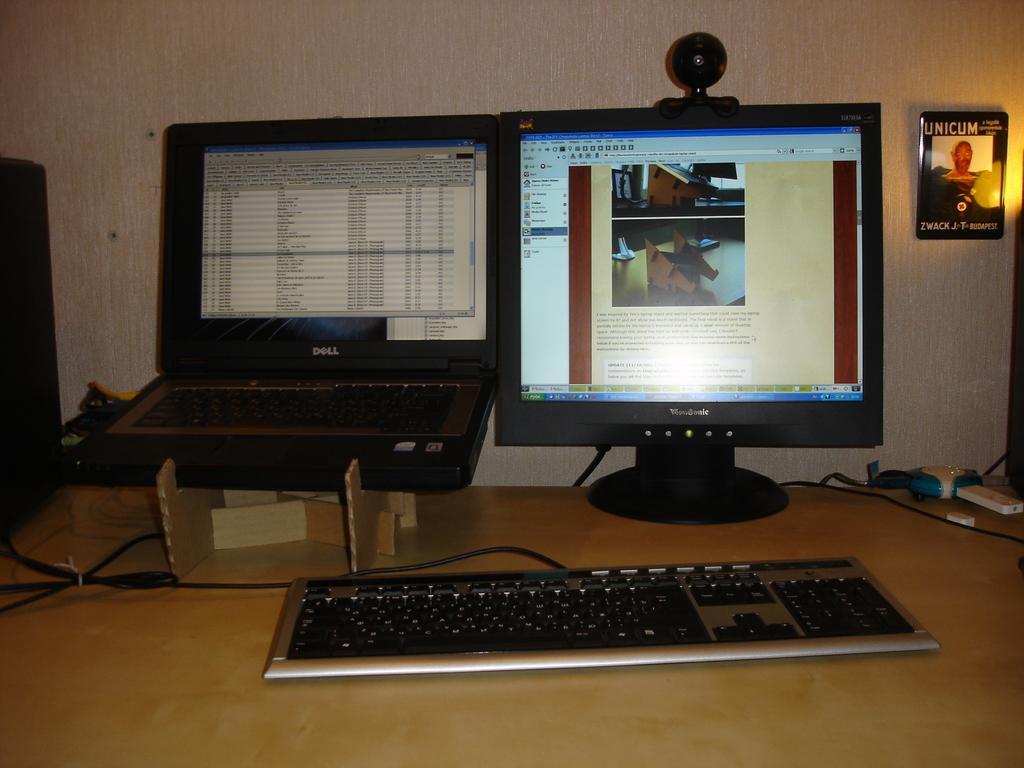Describe this image in one or two sentences. In this image I can see a keyboard, a monitor and a laptop on the table. 